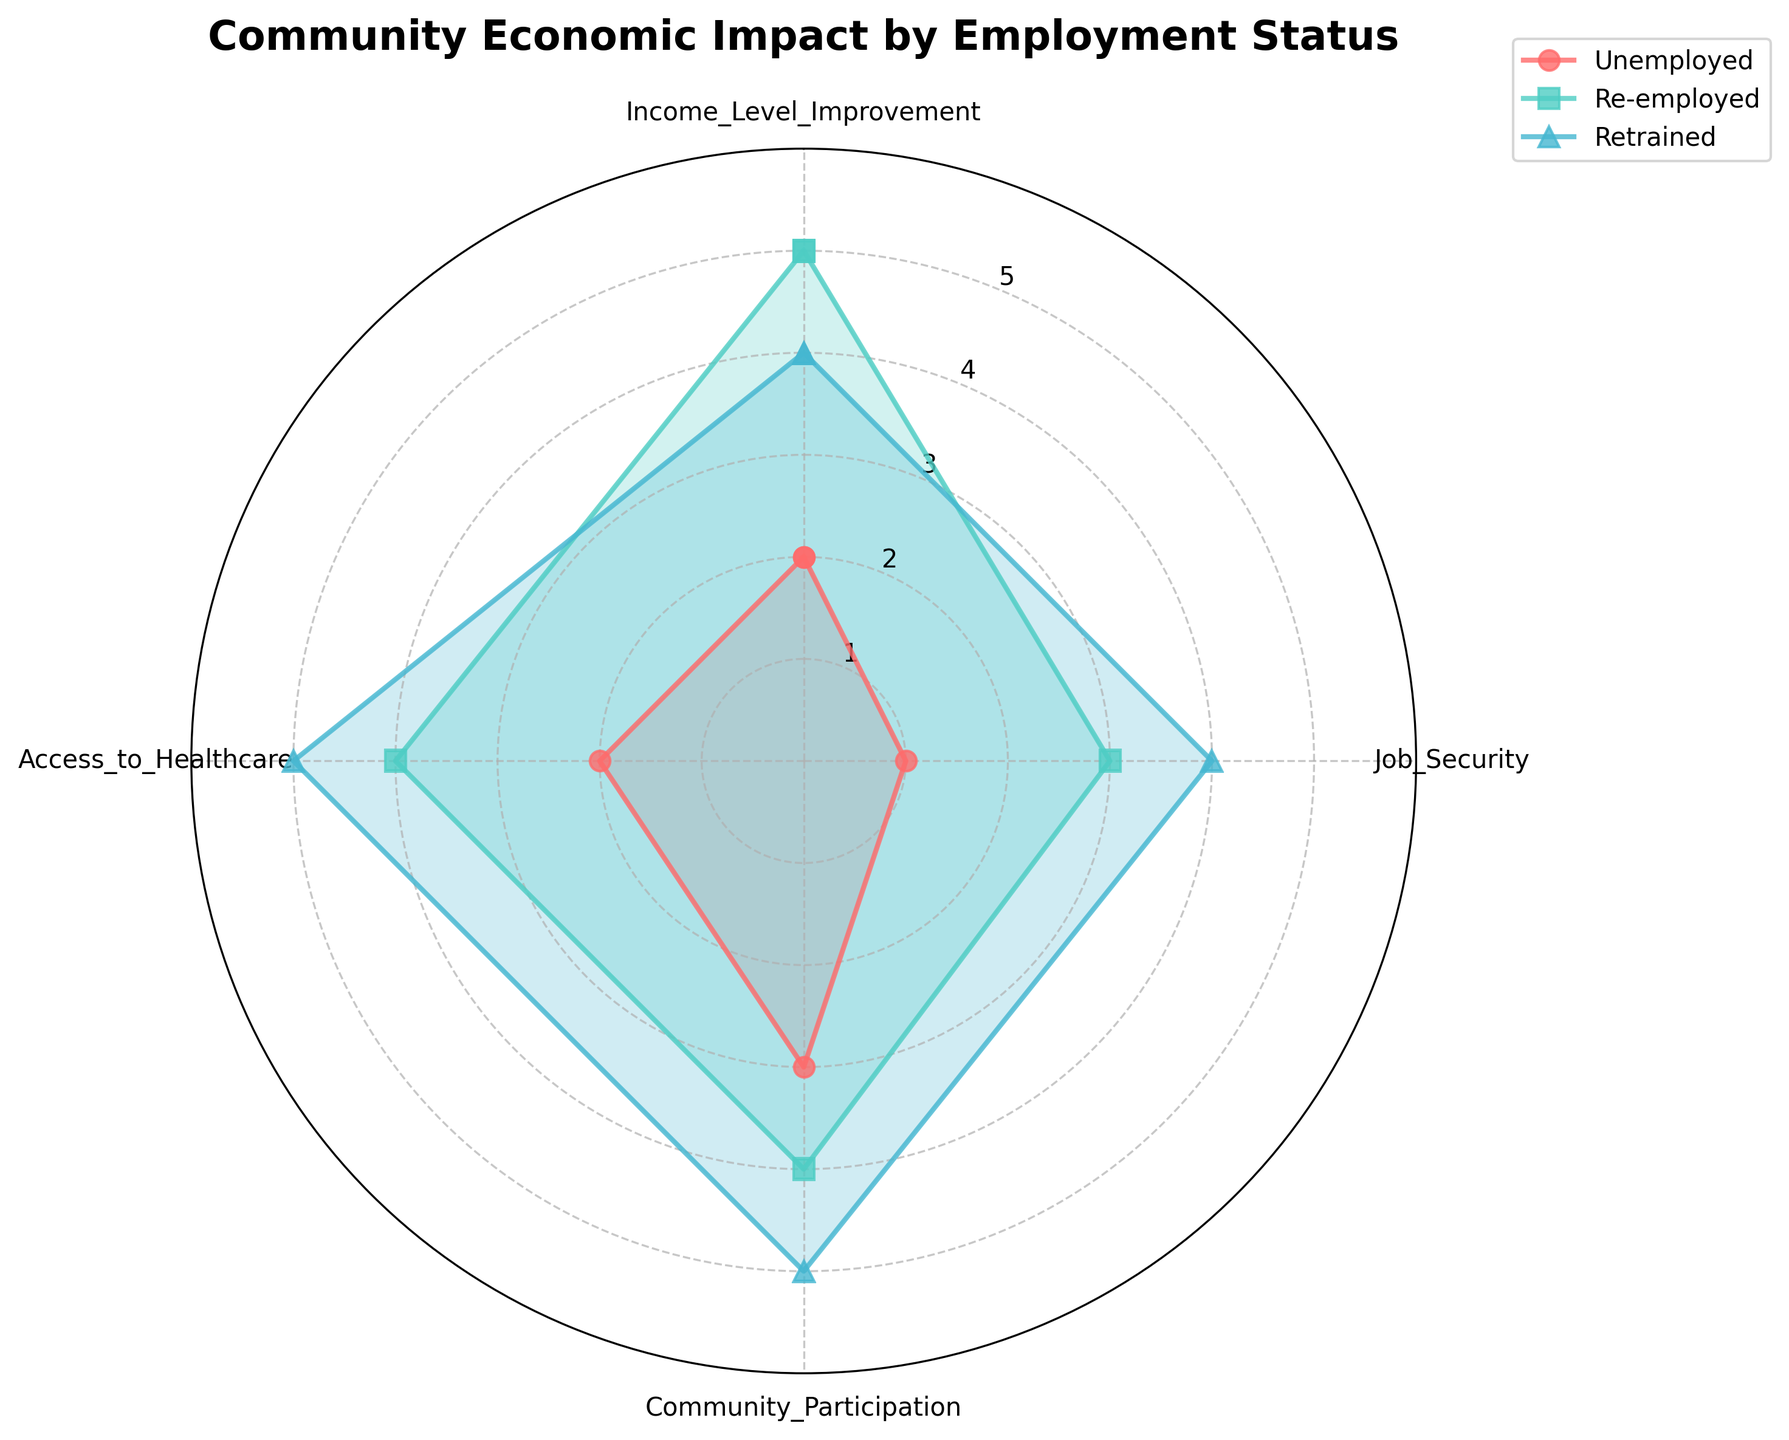What is the title of the figure? The title can be found at the top of the chart.
Answer: Community Economic Impact by Employment Status What are the labels for the axes? The axes are labeled with categories describing community economic impact factors.
Answer: Income Level Improvement, Job Security, Community Participation, Access to Healthcare Which group has the highest value in Job Security? Look at the value points marked under Job Security for all groups and identify the one with the highest value.
Answer: Retrained What is the difference in Community Participation between Unemployed and Retrained? Compare the values for Community Participation: Unemployed has 3 and Retrained has 5. The difference is calculated as 5 - 3.
Answer: 2 Which employment status group has the lowest overall values? Compare the values across all the categories for each group and find the one with the lowest values: i.e., Unemployed has 2, 1, 3, 2 for a total of 8.
Answer: Unemployed How does the Access to Healthcare for the Re-employed group compare to the Unemployed group? Look at the Access to Healthcare values: Re-employed has 4, Unemployed has 2. Compare 4 to 2.
Answer: Re-employed group has a higher value Which category shows the largest improvement for the Retrained group compared to the Unemployed group? Subtract the Unemployed group's values from the Retrained group's values in each category and find the highest difference: (Income Level Improvement: 4-2=2, Job Security: 4-1=3, Community Participation: 5-3=2, Access to Healthcare: 5-2=3).
Answer: Job Security and Access to Healthcare What is the average value for the Re-employed group across all categories? Sum all values for Re-employed (5, 3, 4, 4) and divide by the number of categories (4): (5+3+4+4)/4 = 16/4.
Answer: 4 Which groups show the highest values in Community Participation? Compare the values for Community Participation (Unemployed: 3, Re-employed: 4, Retrained: 5) and pick the highest.
Answer: Retrained 